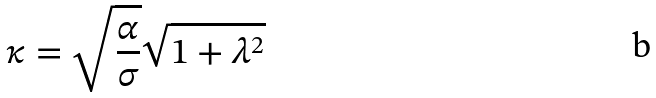Convert formula to latex. <formula><loc_0><loc_0><loc_500><loc_500>\kappa = \sqrt { \frac { \alpha } { \sigma } } \sqrt { 1 + \lambda ^ { 2 } }</formula> 